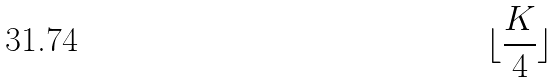Convert formula to latex. <formula><loc_0><loc_0><loc_500><loc_500>\lfloor \frac { K } { 4 } \rfloor</formula> 